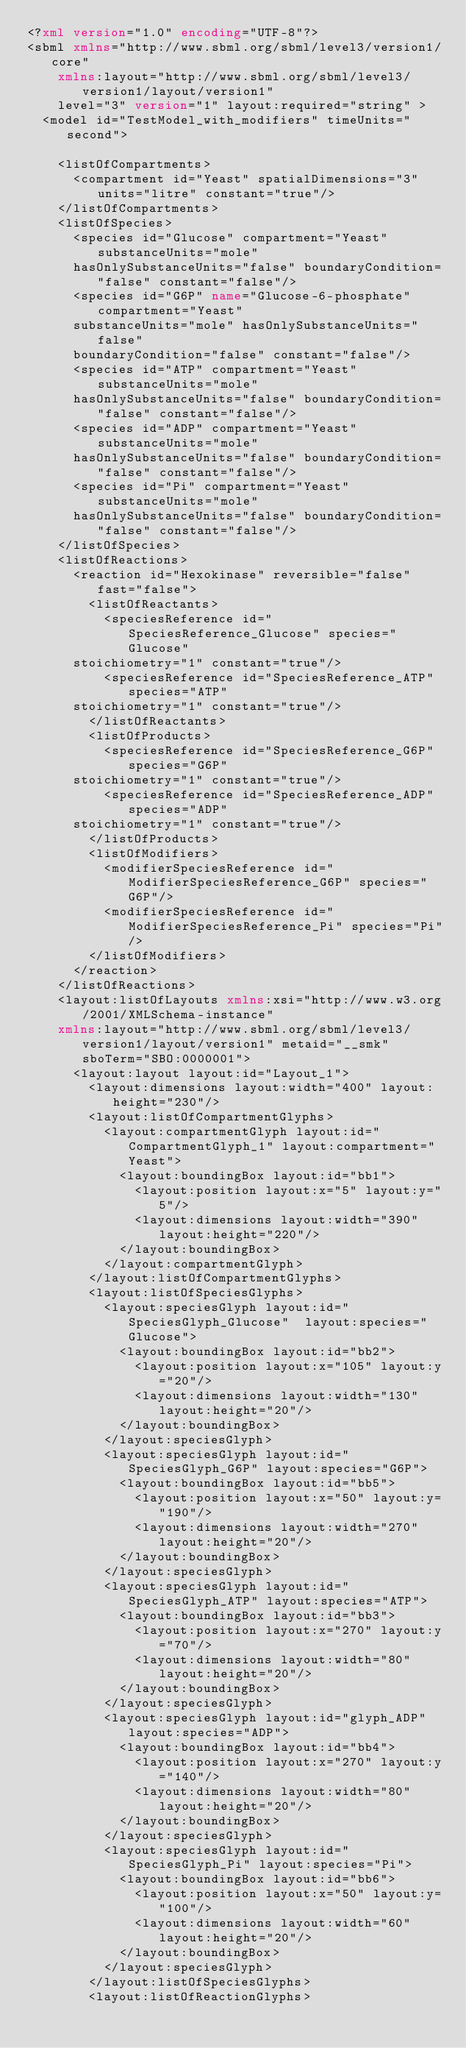Convert code to text. <code><loc_0><loc_0><loc_500><loc_500><_XML_><?xml version="1.0" encoding="UTF-8"?>
<sbml xmlns="http://www.sbml.org/sbml/level3/version1/core" 
		xmlns:layout="http://www.sbml.org/sbml/level3/version1/layout/version1" 
		level="3" version="1" layout:required="string" >
  <model id="TestModel_with_modifiers" timeUnits="second">
    
    <listOfCompartments>
      <compartment id="Yeast" spatialDimensions="3" units="litre" constant="true"/>
    </listOfCompartments>
    <listOfSpecies>
      <species id="Glucose" compartment="Yeast" substanceUnits="mole" 
			hasOnlySubstanceUnits="false" boundaryCondition="false" constant="false"/>
      <species id="G6P" name="Glucose-6-phosphate" compartment="Yeast" 
			substanceUnits="mole" hasOnlySubstanceUnits="false" 
			boundaryCondition="false" constant="false"/>
      <species id="ATP" compartment="Yeast" substanceUnits="mole" 
			hasOnlySubstanceUnits="false" boundaryCondition="false" constant="false"/>
      <species id="ADP" compartment="Yeast" substanceUnits="mole" 
			hasOnlySubstanceUnits="false" boundaryCondition="false" constant="false"/>
      <species id="Pi" compartment="Yeast" substanceUnits="mole" 
			hasOnlySubstanceUnits="false" boundaryCondition="false" constant="false"/>
    </listOfSpecies>
    <listOfReactions>
      <reaction id="Hexokinase" reversible="false" fast="false">
        <listOfReactants>
          <speciesReference id="SpeciesReference_Glucose" species="Glucose" 
			stoichiometry="1" constant="true"/>
          <speciesReference id="SpeciesReference_ATP" species="ATP" 
			stoichiometry="1" constant="true"/>
        </listOfReactants>
        <listOfProducts>
          <speciesReference id="SpeciesReference_G6P" species="G6P" 
			stoichiometry="1" constant="true"/>
          <speciesReference id="SpeciesReference_ADP" species="ADP" 
			stoichiometry="1" constant="true"/>
        </listOfProducts>
        <listOfModifiers>
          <modifierSpeciesReference id="ModifierSpeciesReference_G6P" species="G6P"/>
          <modifierSpeciesReference id="ModifierSpeciesReference_Pi" species="Pi"/>
        </listOfModifiers>
      </reaction>
    </listOfReactions>
    <layout:listOfLayouts xmlns:xsi="http://www.w3.org/2001/XMLSchema-instance" 
		xmlns:layout="http://www.sbml.org/sbml/level3/version1/layout/version1" metaid="__smk" sboTerm="SBO:0000001">
      <layout:layout layout:id="Layout_1">
        <layout:dimensions layout:width="400" layout:height="230"/>
        <layout:listOfCompartmentGlyphs>
          <layout:compartmentGlyph layout:id="CompartmentGlyph_1" layout:compartment="Yeast">
            <layout:boundingBox layout:id="bb1">
              <layout:position layout:x="5" layout:y="5"/>
              <layout:dimensions layout:width="390" layout:height="220"/>
            </layout:boundingBox>
          </layout:compartmentGlyph>
        </layout:listOfCompartmentGlyphs>
        <layout:listOfSpeciesGlyphs>
          <layout:speciesGlyph layout:id="SpeciesGlyph_Glucose"  layout:species="Glucose">
            <layout:boundingBox layout:id="bb2">
              <layout:position layout:x="105" layout:y="20"/>
              <layout:dimensions layout:width="130" layout:height="20"/>
            </layout:boundingBox>
          </layout:speciesGlyph>
          <layout:speciesGlyph layout:id="SpeciesGlyph_G6P" layout:species="G6P">
            <layout:boundingBox layout:id="bb5">
              <layout:position layout:x="50" layout:y="190"/>
              <layout:dimensions layout:width="270" layout:height="20"/>
            </layout:boundingBox>
          </layout:speciesGlyph>
          <layout:speciesGlyph layout:id="SpeciesGlyph_ATP" layout:species="ATP">
            <layout:boundingBox layout:id="bb3">
              <layout:position layout:x="270" layout:y="70"/>
              <layout:dimensions layout:width="80" layout:height="20"/>
            </layout:boundingBox>
          </layout:speciesGlyph>
          <layout:speciesGlyph layout:id="glyph_ADP" layout:species="ADP">
            <layout:boundingBox layout:id="bb4">
              <layout:position layout:x="270" layout:y="140"/>
              <layout:dimensions layout:width="80" layout:height="20"/>
            </layout:boundingBox>
          </layout:speciesGlyph>
          <layout:speciesGlyph layout:id="SpeciesGlyph_Pi" layout:species="Pi">
            <layout:boundingBox layout:id="bb6">
              <layout:position layout:x="50" layout:y="100"/>
              <layout:dimensions layout:width="60" layout:height="20"/>
            </layout:boundingBox>
          </layout:speciesGlyph>
        </layout:listOfSpeciesGlyphs>
        <layout:listOfReactionGlyphs></code> 